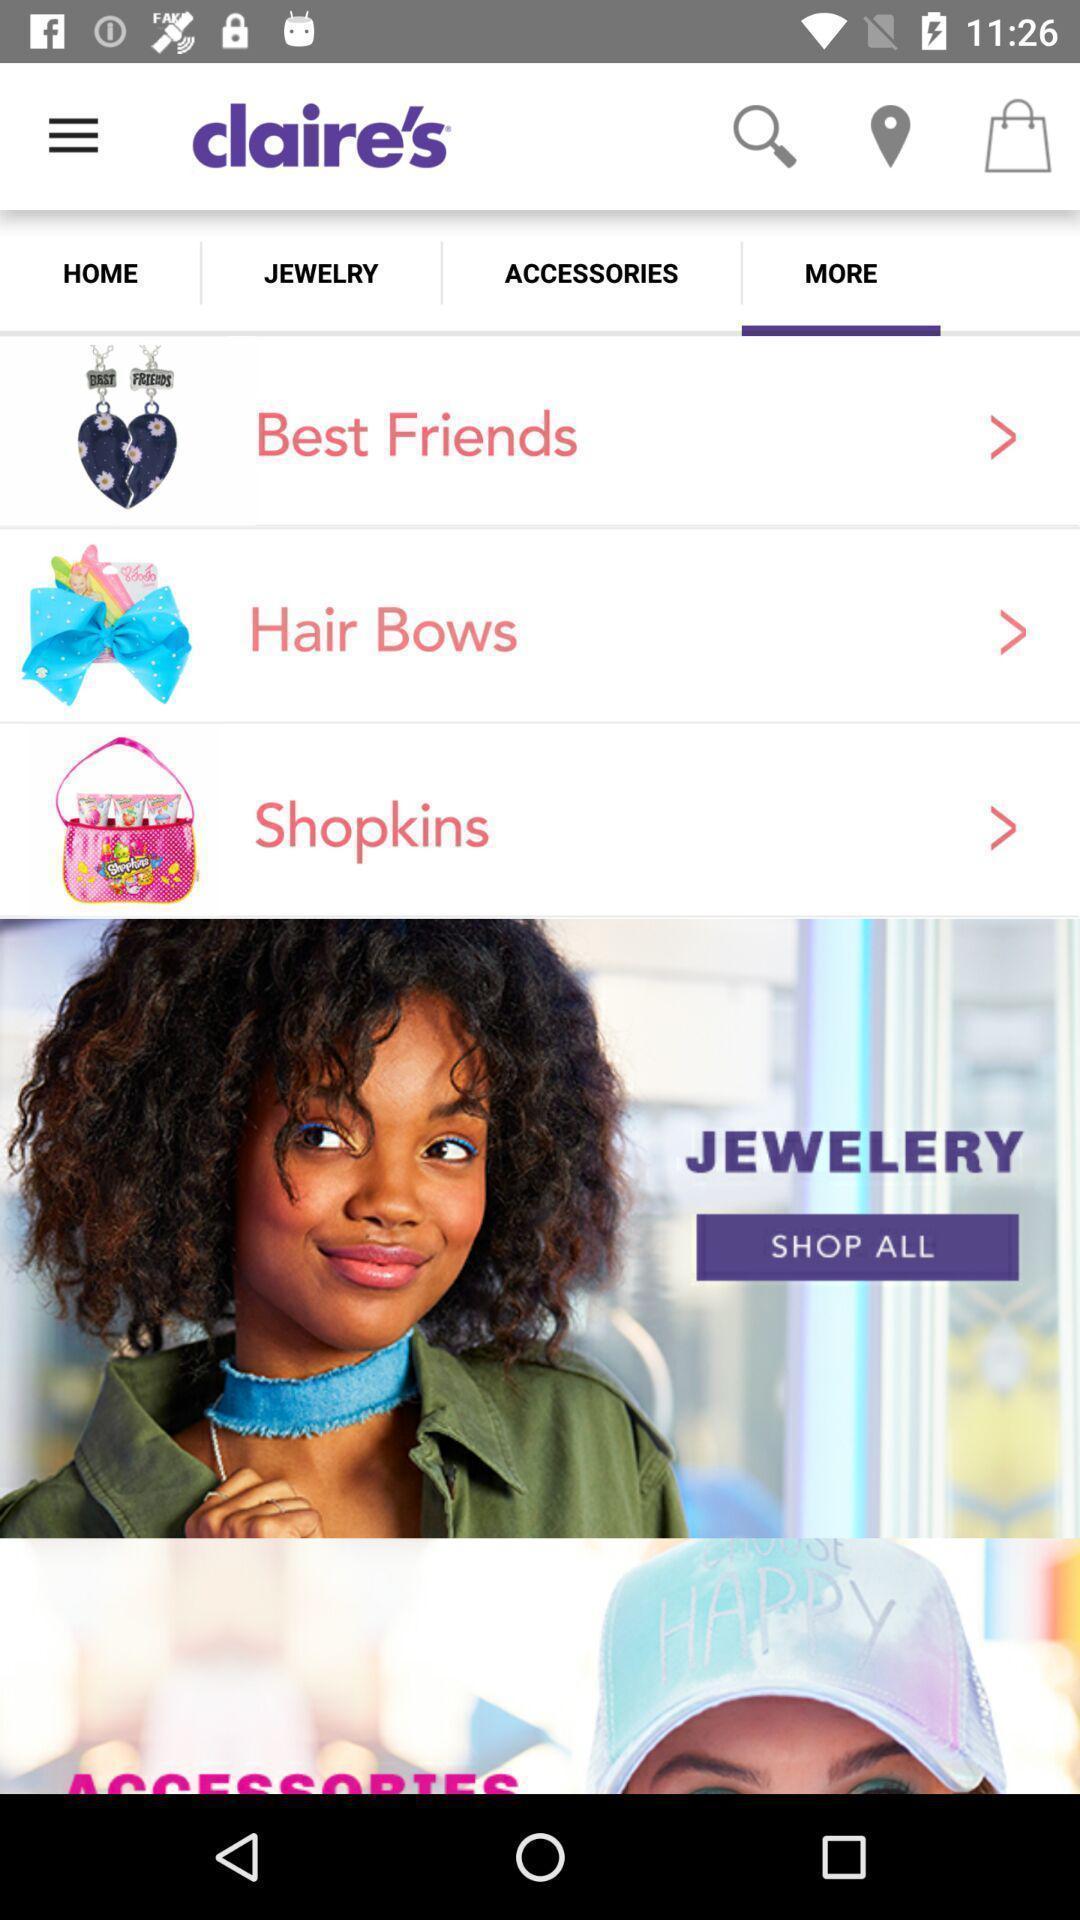Give me a summary of this screen capture. Screen displaying page of an shopping application. 